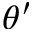Convert formula to latex. <formula><loc_0><loc_0><loc_500><loc_500>\theta ^ { \prime }</formula> 